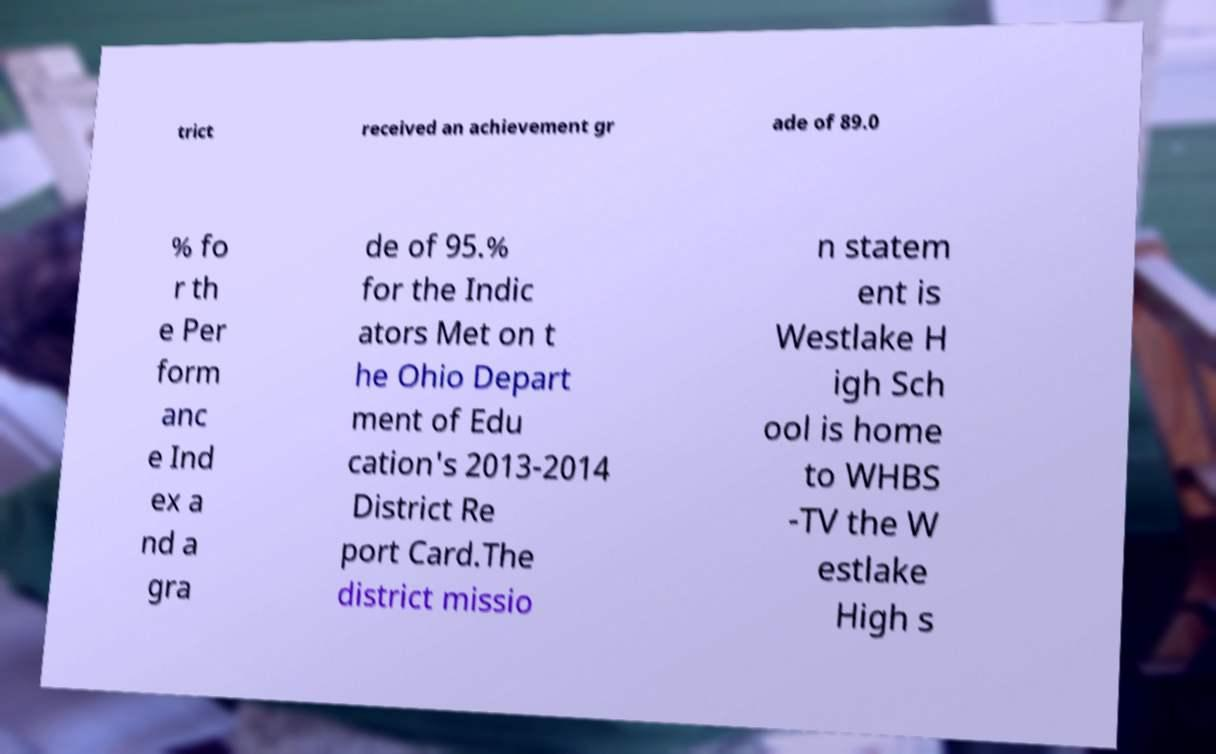Can you read and provide the text displayed in the image?This photo seems to have some interesting text. Can you extract and type it out for me? trict received an achievement gr ade of 89.0 % fo r th e Per form anc e Ind ex a nd a gra de of 95.% for the Indic ators Met on t he Ohio Depart ment of Edu cation's 2013-2014 District Re port Card.The district missio n statem ent is Westlake H igh Sch ool is home to WHBS -TV the W estlake High s 